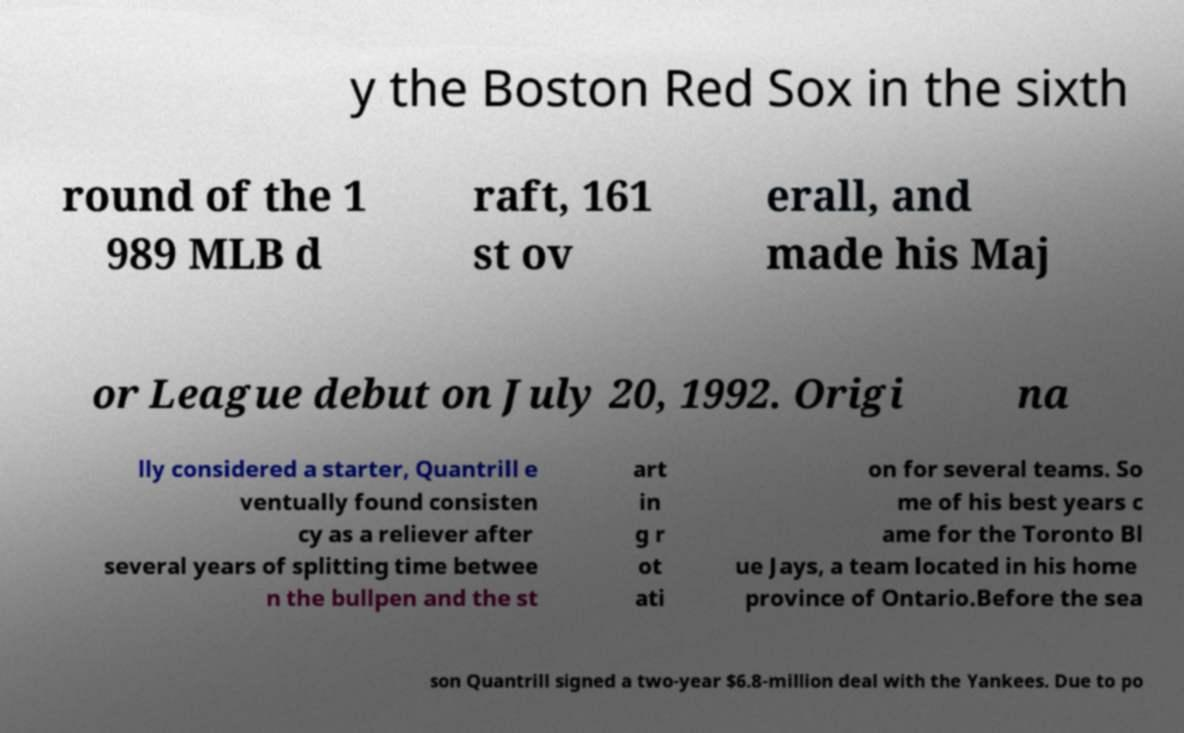What messages or text are displayed in this image? I need them in a readable, typed format. y the Boston Red Sox in the sixth round of the 1 989 MLB d raft, 161 st ov erall, and made his Maj or League debut on July 20, 1992. Origi na lly considered a starter, Quantrill e ventually found consisten cy as a reliever after several years of splitting time betwee n the bullpen and the st art in g r ot ati on for several teams. So me of his best years c ame for the Toronto Bl ue Jays, a team located in his home province of Ontario.Before the sea son Quantrill signed a two-year $6.8-million deal with the Yankees. Due to po 